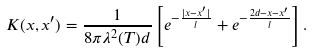Convert formula to latex. <formula><loc_0><loc_0><loc_500><loc_500>K ( x , x ^ { \prime } ) = \frac { 1 } { 8 \pi \lambda ^ { 2 } ( T ) d } \left [ e ^ { - \frac { | x - x ^ { \prime } | } { l } } + e ^ { - \frac { 2 d - x - x ^ { \prime } } { l } } \right ] .</formula> 